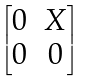<formula> <loc_0><loc_0><loc_500><loc_500>\begin{bmatrix} 0 & X \\ 0 & 0 \end{bmatrix}</formula> 